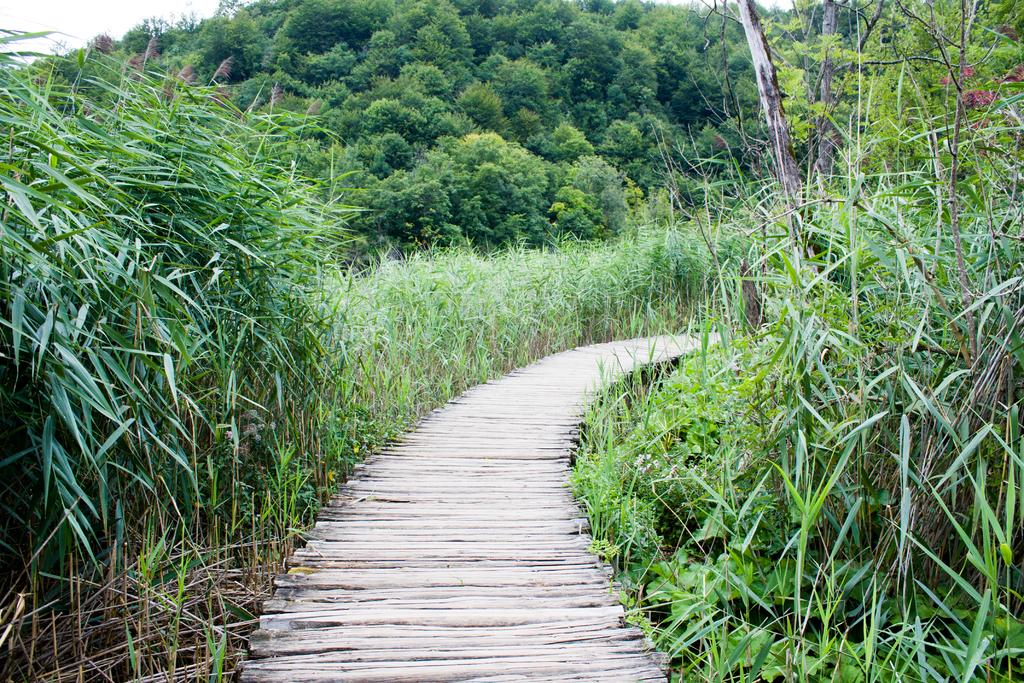What type of vegetation can be seen on both sides of the image? There are trees and plants on both the right and left sides of the image. What is located in the middle of the image? There is a path in the middle of the image. Can you see any sticks or masks in the image? There are no sticks or masks present in the image. Is there a carriage visible in the image? There is no carriage present in the image. 